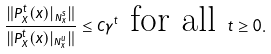<formula> <loc_0><loc_0><loc_500><loc_500>\frac { \| P _ { X } ^ { t } ( x ) | _ { { N } ^ { s } _ { x } } \| } { \| P _ { X } ^ { t } ( x ) | _ { { N } ^ { u } _ { x } } \| } \leq { C \gamma ^ { t } } \text { for all } t \geq 0 .</formula> 